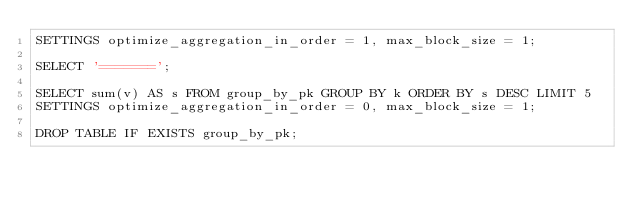Convert code to text. <code><loc_0><loc_0><loc_500><loc_500><_SQL_>SETTINGS optimize_aggregation_in_order = 1, max_block_size = 1;

SELECT '=======';

SELECT sum(v) AS s FROM group_by_pk GROUP BY k ORDER BY s DESC LIMIT 5
SETTINGS optimize_aggregation_in_order = 0, max_block_size = 1;

DROP TABLE IF EXISTS group_by_pk;
</code> 